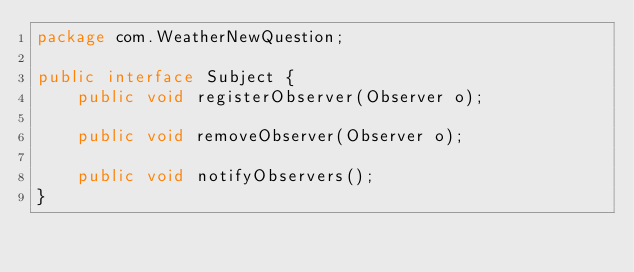<code> <loc_0><loc_0><loc_500><loc_500><_Java_>package com.WeatherNewQuestion;

public interface Subject {
	public void registerObserver(Observer o);

	public void removeObserver(Observer o);

	public void notifyObservers();
}
</code> 